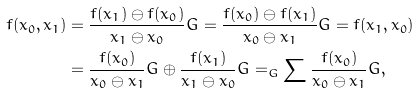Convert formula to latex. <formula><loc_0><loc_0><loc_500><loc_500>f ( x _ { 0 } , x _ { 1 } ) & = \frac { f ( x _ { 1 } ) \ominus f ( x _ { 0 } ) } { x _ { 1 } \ominus x _ { 0 } } G = \frac { f ( x _ { 0 } ) \ominus f ( x _ { 1 } ) } { x _ { 0 } \ominus x _ { 1 } } G = f ( x _ { 1 } , x _ { 0 } ) \\ & = \frac { f ( x _ { 0 } ) } { x _ { 0 } \ominus x _ { 1 } } G \oplus \frac { f ( x _ { 1 } ) } { x _ { 1 } \ominus x _ { 0 } } G = _ { G } \sum \frac { f ( x _ { 0 } ) } { x _ { 0 } \ominus x _ { 1 } } G ,</formula> 